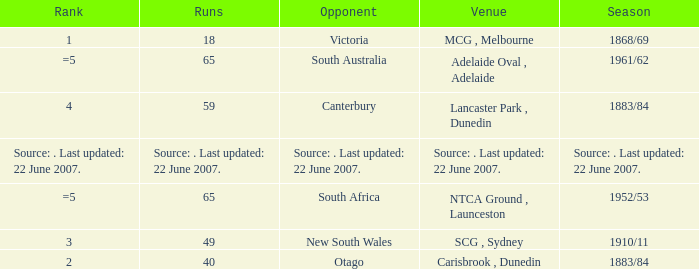Which Runs has a Opponent of south australia? 65.0. 